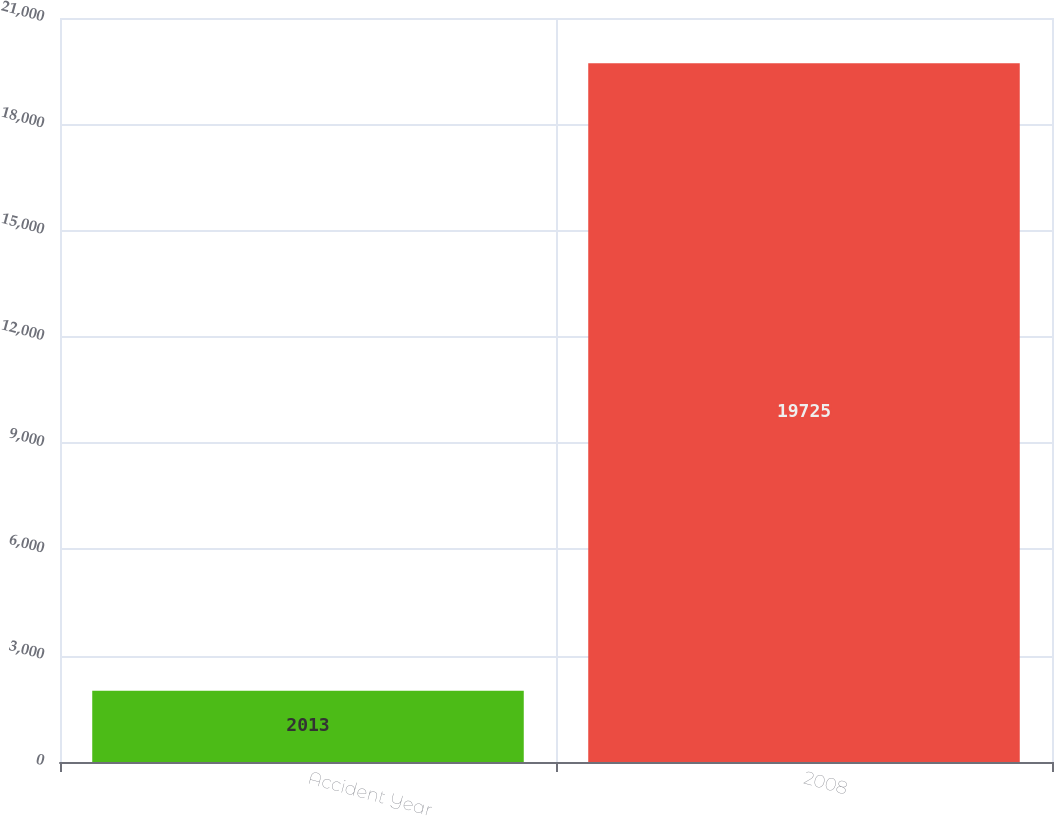Convert chart to OTSL. <chart><loc_0><loc_0><loc_500><loc_500><bar_chart><fcel>Accident Year<fcel>2008<nl><fcel>2013<fcel>19725<nl></chart> 